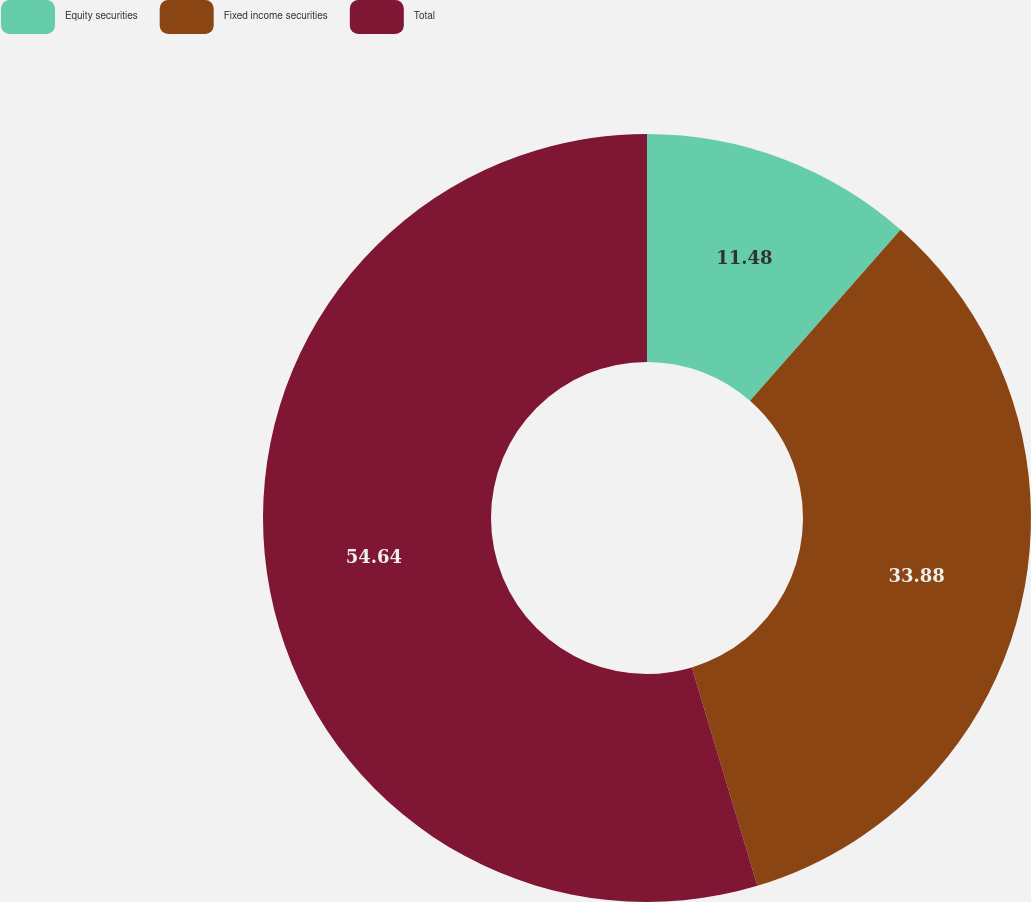<chart> <loc_0><loc_0><loc_500><loc_500><pie_chart><fcel>Equity securities<fcel>Fixed income securities<fcel>Total<nl><fcel>11.48%<fcel>33.88%<fcel>54.64%<nl></chart> 